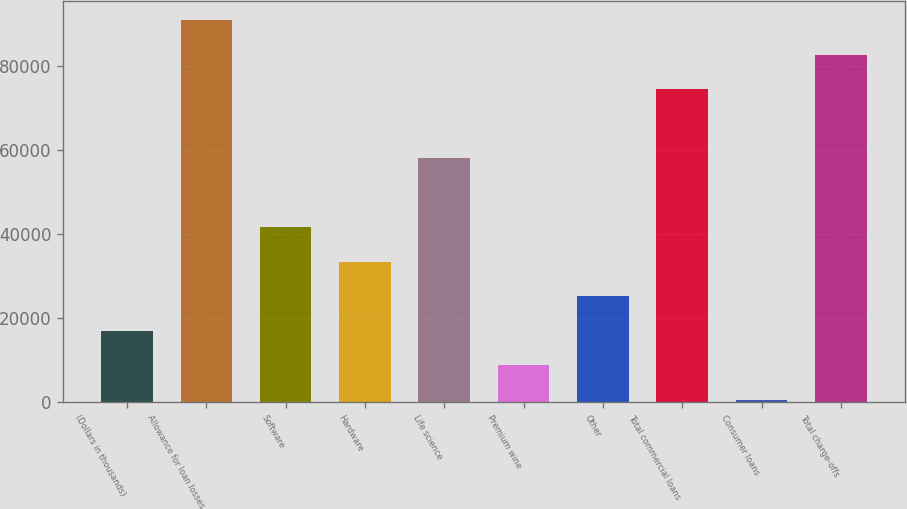Convert chart to OTSL. <chart><loc_0><loc_0><loc_500><loc_500><bar_chart><fcel>(Dollars in thousands)<fcel>Allowance for loan losses<fcel>Software<fcel>Hardware<fcel>Life science<fcel>Premium wine<fcel>Other<fcel>Total commercial loans<fcel>Consumer loans<fcel>Total charge-offs<nl><fcel>16916.6<fcel>90840.8<fcel>41558<fcel>33344.2<fcel>57985.6<fcel>8702.8<fcel>25130.4<fcel>74413.2<fcel>489<fcel>82627<nl></chart> 